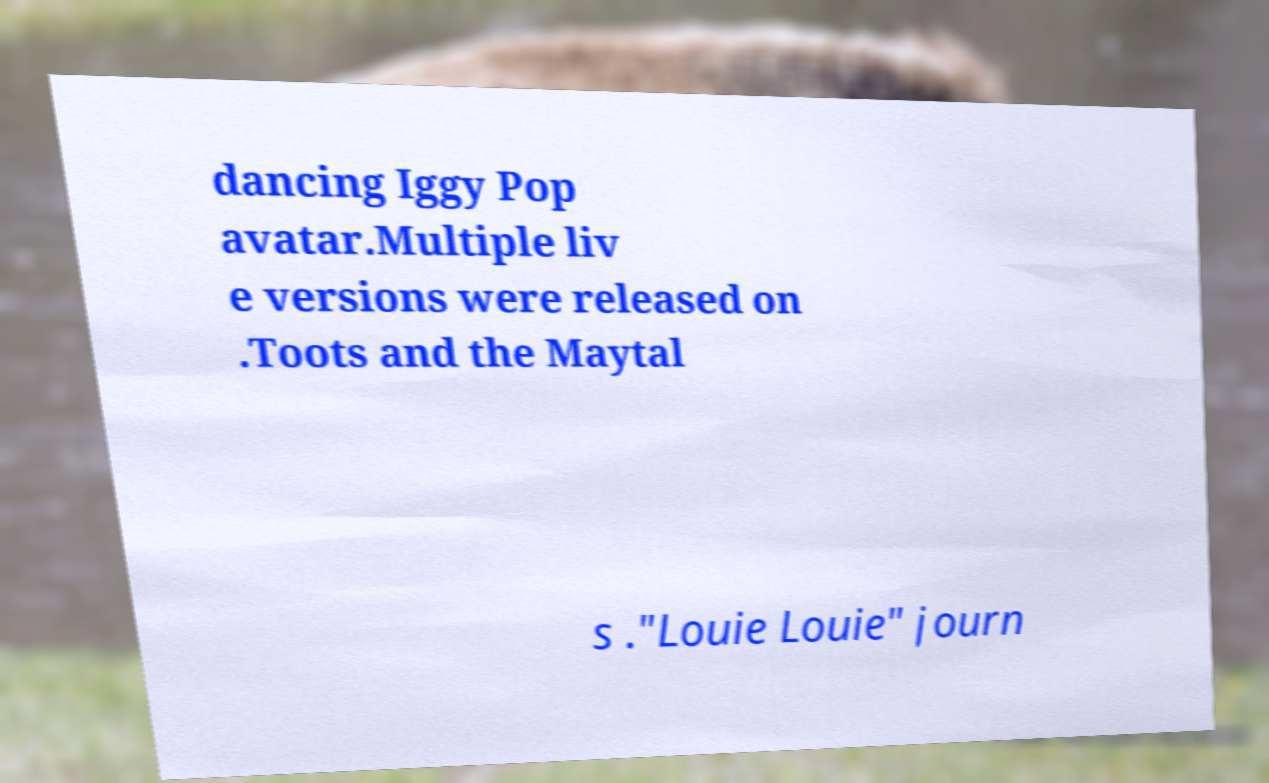Can you accurately transcribe the text from the provided image for me? dancing Iggy Pop avatar.Multiple liv e versions were released on .Toots and the Maytal s ."Louie Louie" journ 